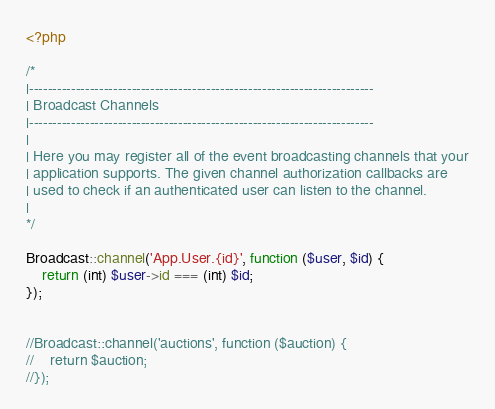<code> <loc_0><loc_0><loc_500><loc_500><_PHP_><?php

/*
|--------------------------------------------------------------------------
| Broadcast Channels
|--------------------------------------------------------------------------
|
| Here you may register all of the event broadcasting channels that your
| application supports. The given channel authorization callbacks are
| used to check if an authenticated user can listen to the channel.
|
*/

Broadcast::channel('App.User.{id}', function ($user, $id) {
    return (int) $user->id === (int) $id;
});


//Broadcast::channel('auctions', function ($auction) {
//    return $auction;
//});
</code> 